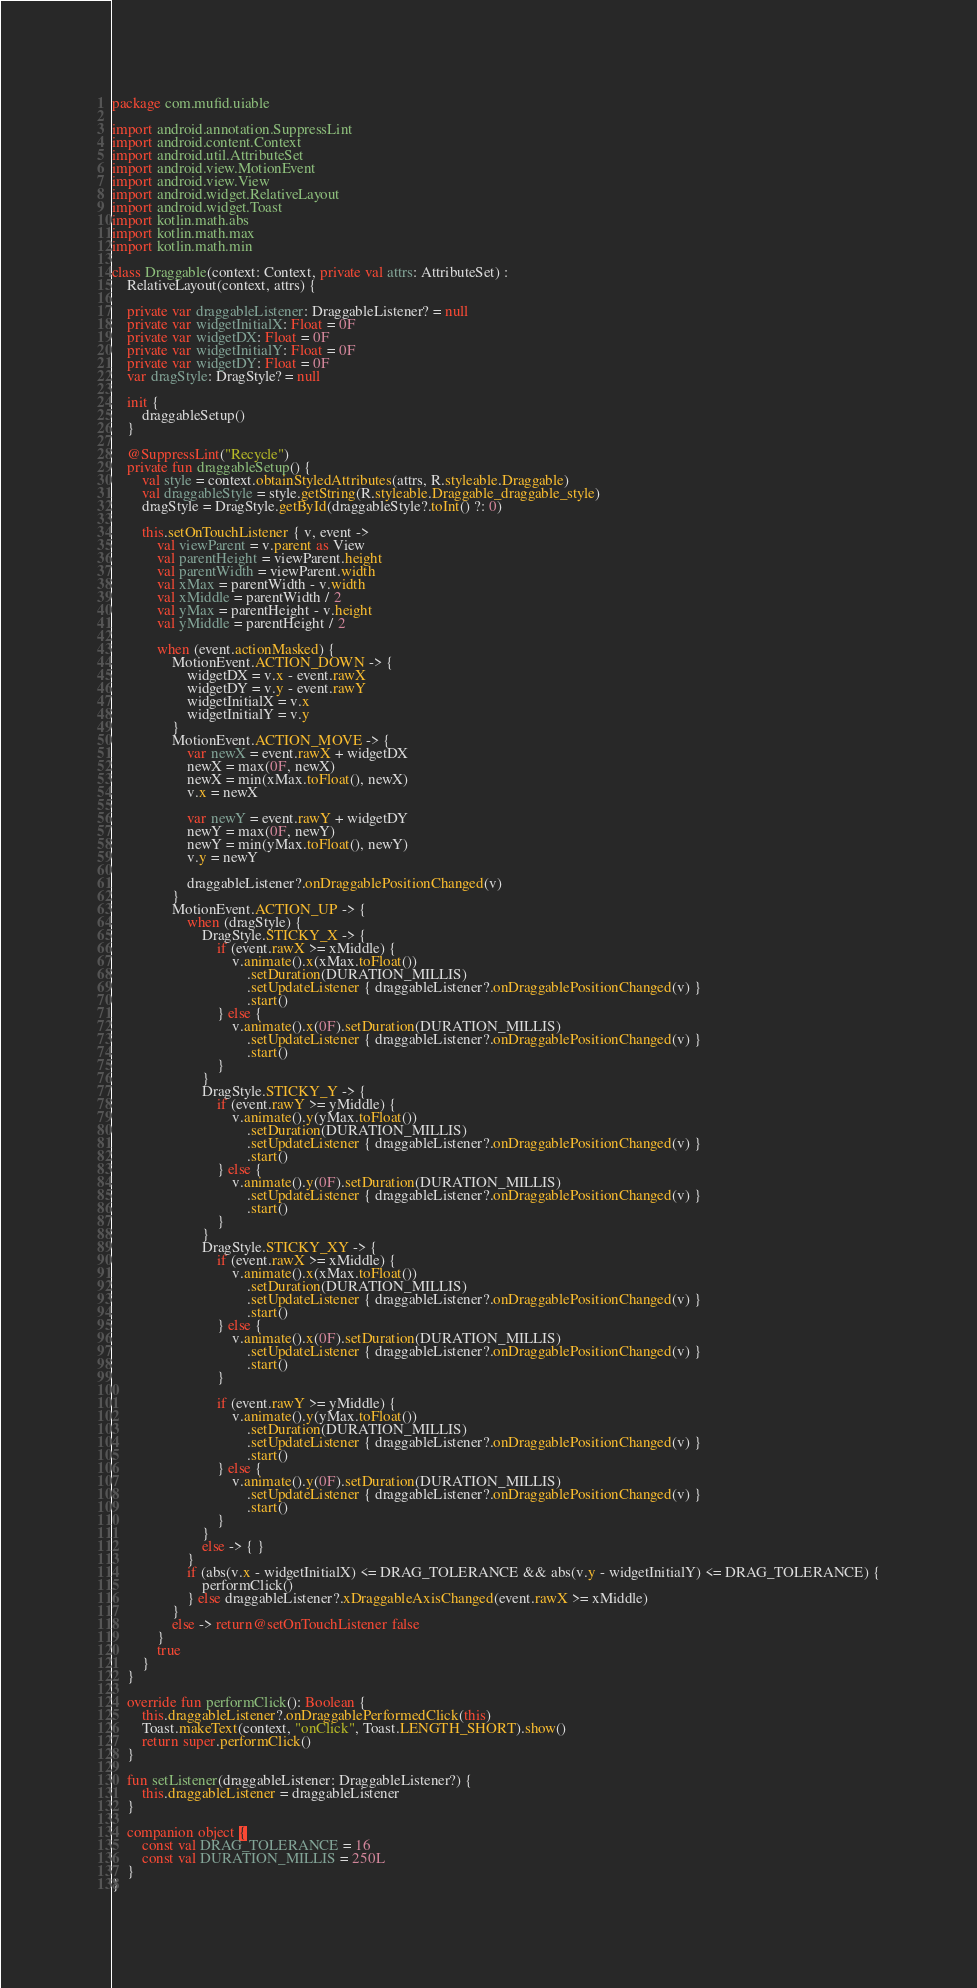Convert code to text. <code><loc_0><loc_0><loc_500><loc_500><_Kotlin_>package com.mufid.uiable

import android.annotation.SuppressLint
import android.content.Context
import android.util.AttributeSet
import android.view.MotionEvent
import android.view.View
import android.widget.RelativeLayout
import android.widget.Toast
import kotlin.math.abs
import kotlin.math.max
import kotlin.math.min

class Draggable(context: Context, private val attrs: AttributeSet) :
    RelativeLayout(context, attrs) {

    private var draggableListener: DraggableListener? = null
    private var widgetInitialX: Float = 0F
    private var widgetDX: Float = 0F
    private var widgetInitialY: Float = 0F
    private var widgetDY: Float = 0F
    var dragStyle: DragStyle? = null

    init {
        draggableSetup()
    }

    @SuppressLint("Recycle")
    private fun draggableSetup() {
        val style = context.obtainStyledAttributes(attrs, R.styleable.Draggable)
        val draggableStyle = style.getString(R.styleable.Draggable_draggable_style)
        dragStyle = DragStyle.getById(draggableStyle?.toInt() ?: 0)

        this.setOnTouchListener { v, event ->
            val viewParent = v.parent as View
            val parentHeight = viewParent.height
            val parentWidth = viewParent.width
            val xMax = parentWidth - v.width
            val xMiddle = parentWidth / 2
            val yMax = parentHeight - v.height
            val yMiddle = parentHeight / 2

            when (event.actionMasked) {
                MotionEvent.ACTION_DOWN -> {
                    widgetDX = v.x - event.rawX
                    widgetDY = v.y - event.rawY
                    widgetInitialX = v.x
                    widgetInitialY = v.y
                }
                MotionEvent.ACTION_MOVE -> {
                    var newX = event.rawX + widgetDX
                    newX = max(0F, newX)
                    newX = min(xMax.toFloat(), newX)
                    v.x = newX

                    var newY = event.rawY + widgetDY
                    newY = max(0F, newY)
                    newY = min(yMax.toFloat(), newY)
                    v.y = newY

                    draggableListener?.onDraggablePositionChanged(v)
                }
                MotionEvent.ACTION_UP -> {
                    when (dragStyle) {
                        DragStyle.STICKY_X -> {
                            if (event.rawX >= xMiddle) {
                                v.animate().x(xMax.toFloat())
                                    .setDuration(DURATION_MILLIS)
                                    .setUpdateListener { draggableListener?.onDraggablePositionChanged(v) }
                                    .start()
                            } else {
                                v.animate().x(0F).setDuration(DURATION_MILLIS)
                                    .setUpdateListener { draggableListener?.onDraggablePositionChanged(v) }
                                    .start()
                            }
                        }
                        DragStyle.STICKY_Y -> {
                            if (event.rawY >= yMiddle) {
                                v.animate().y(yMax.toFloat())
                                    .setDuration(DURATION_MILLIS)
                                    .setUpdateListener { draggableListener?.onDraggablePositionChanged(v) }
                                    .start()
                            } else {
                                v.animate().y(0F).setDuration(DURATION_MILLIS)
                                    .setUpdateListener { draggableListener?.onDraggablePositionChanged(v) }
                                    .start()
                            }
                        }
                        DragStyle.STICKY_XY -> {
                            if (event.rawX >= xMiddle) {
                                v.animate().x(xMax.toFloat())
                                    .setDuration(DURATION_MILLIS)
                                    .setUpdateListener { draggableListener?.onDraggablePositionChanged(v) }
                                    .start()
                            } else {
                                v.animate().x(0F).setDuration(DURATION_MILLIS)
                                    .setUpdateListener { draggableListener?.onDraggablePositionChanged(v) }
                                    .start()
                            }

                            if (event.rawY >= yMiddle) {
                                v.animate().y(yMax.toFloat())
                                    .setDuration(DURATION_MILLIS)
                                    .setUpdateListener { draggableListener?.onDraggablePositionChanged(v) }
                                    .start()
                            } else {
                                v.animate().y(0F).setDuration(DURATION_MILLIS)
                                    .setUpdateListener { draggableListener?.onDraggablePositionChanged(v) }
                                    .start()
                            }
                        }
                        else -> { }
                    }
                    if (abs(v.x - widgetInitialX) <= DRAG_TOLERANCE && abs(v.y - widgetInitialY) <= DRAG_TOLERANCE) {
                        performClick()
                    } else draggableListener?.xDraggableAxisChanged(event.rawX >= xMiddle)
                }
                else -> return@setOnTouchListener false
            }
            true
        }
    }

    override fun performClick(): Boolean {
        this.draggableListener?.onDraggablePerformedClick(this)
        Toast.makeText(context, "onClick", Toast.LENGTH_SHORT).show()
        return super.performClick()
    }

    fun setListener(draggableListener: DraggableListener?) {
        this.draggableListener = draggableListener
    }

    companion object {
        const val DRAG_TOLERANCE = 16
        const val DURATION_MILLIS = 250L
    }
}</code> 